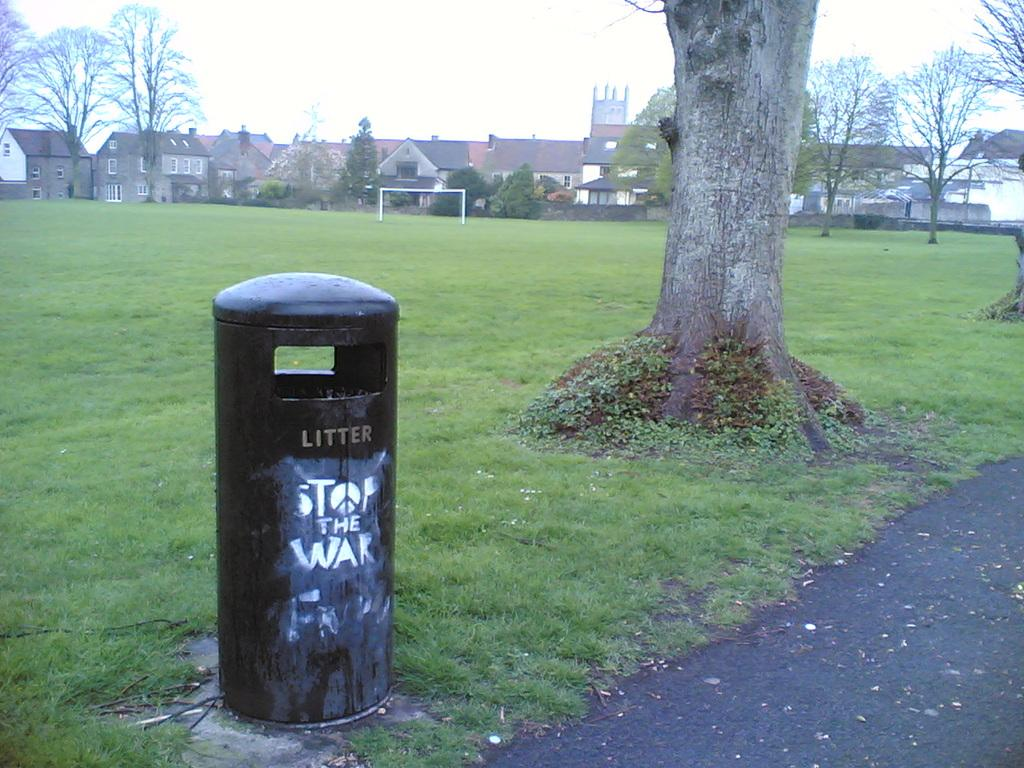<image>
Share a concise interpretation of the image provided. A garbage can in a park that reads LITTER and STOP THE WAR. 